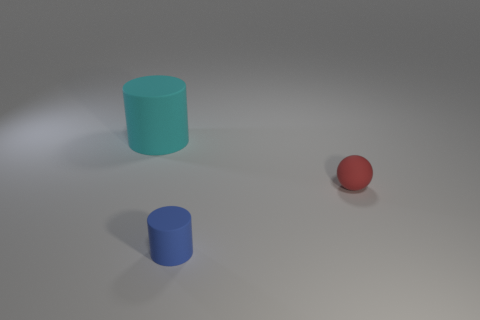Is there any other thing that is the same size as the cyan matte object?
Offer a very short reply. No. How many cubes are blue objects or tiny objects?
Provide a short and direct response. 0. What is the size of the cylinder behind the thing in front of the small red ball?
Provide a succinct answer. Large. What number of small cylinders are on the left side of the cyan cylinder?
Provide a succinct answer. 0. Are there fewer tiny brown matte cylinders than blue matte objects?
Ensure brevity in your answer.  Yes. What is the size of the rubber thing that is both on the left side of the sphere and in front of the cyan rubber cylinder?
Offer a terse response. Small. Is the number of small rubber objects left of the big cyan matte cylinder less than the number of small blue cylinders?
Offer a terse response. Yes. There is a big cyan object that is made of the same material as the small red sphere; what is its shape?
Offer a very short reply. Cylinder. Does the tiny red thing have the same material as the tiny blue thing?
Your answer should be very brief. Yes. Is the number of small matte objects that are left of the matte sphere less than the number of matte objects that are to the right of the cyan rubber cylinder?
Provide a short and direct response. Yes. 